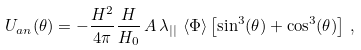Convert formula to latex. <formula><loc_0><loc_0><loc_500><loc_500>U _ { a n } ( \theta ) = - \frac { H ^ { 2 } } { 4 \pi } \frac { H } { H _ { 0 } } \, A \, \lambda _ { | | } \, \left < \Phi \right > \left [ \sin ^ { 3 } ( \theta ) + \cos ^ { 3 } ( \theta ) \right ] \, ,</formula> 